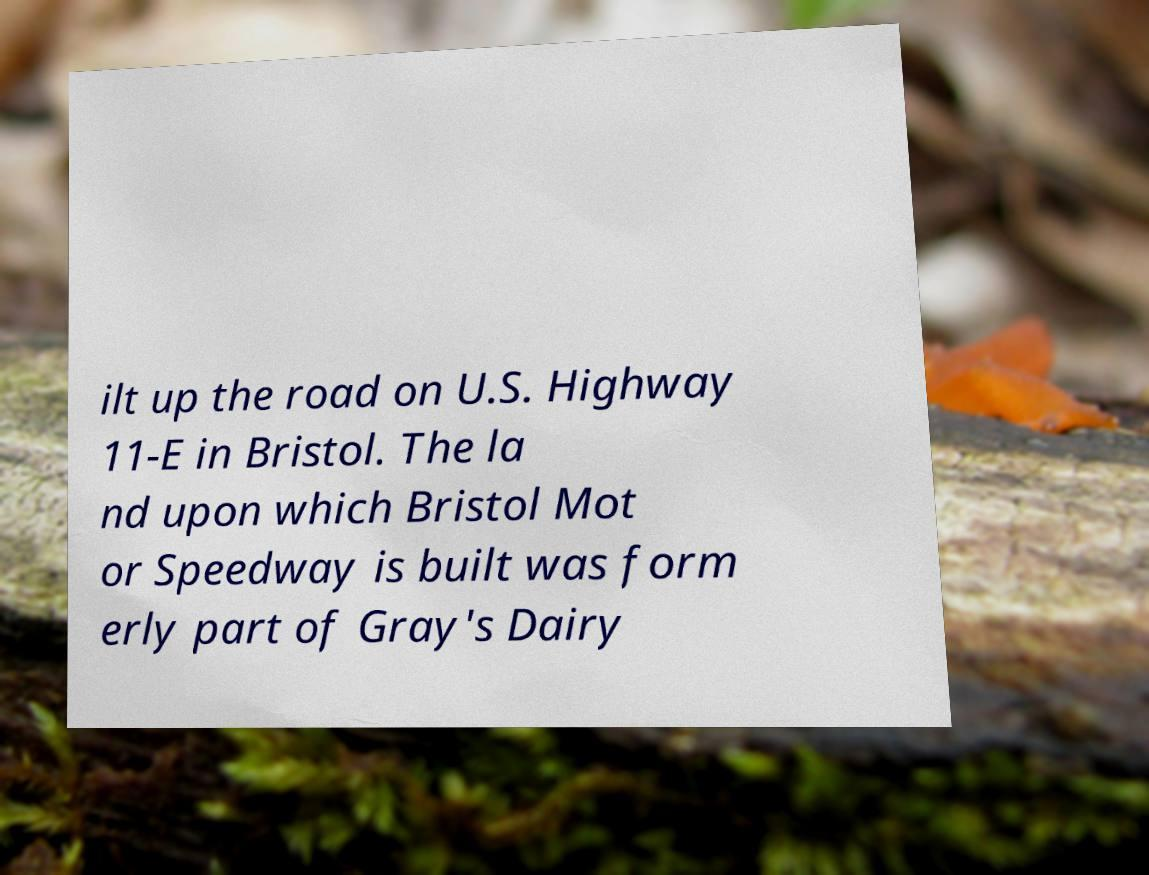Please identify and transcribe the text found in this image. ilt up the road on U.S. Highway 11-E in Bristol. The la nd upon which Bristol Mot or Speedway is built was form erly part of Gray's Dairy 